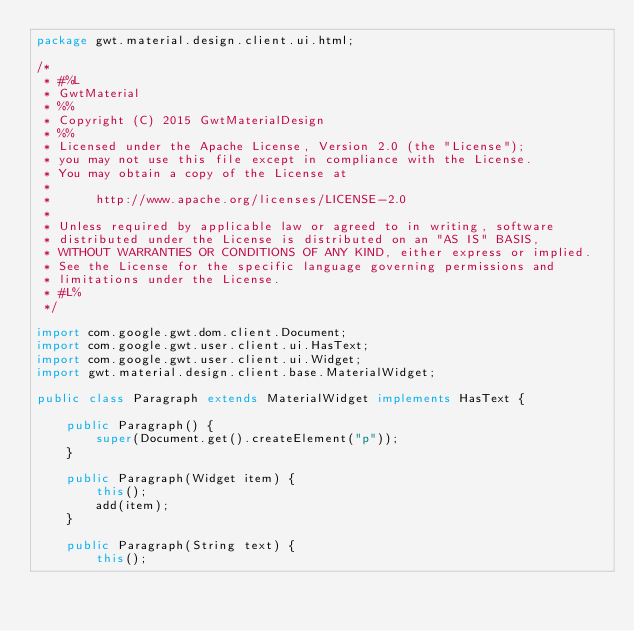Convert code to text. <code><loc_0><loc_0><loc_500><loc_500><_Java_>package gwt.material.design.client.ui.html;

/*
 * #%L
 * GwtMaterial
 * %%
 * Copyright (C) 2015 GwtMaterialDesign
 * %%
 * Licensed under the Apache License, Version 2.0 (the "License");
 * you may not use this file except in compliance with the License.
 * You may obtain a copy of the License at
 * 
 *      http://www.apache.org/licenses/LICENSE-2.0
 * 
 * Unless required by applicable law or agreed to in writing, software
 * distributed under the License is distributed on an "AS IS" BASIS,
 * WITHOUT WARRANTIES OR CONDITIONS OF ANY KIND, either express or implied.
 * See the License for the specific language governing permissions and
 * limitations under the License.
 * #L%
 */

import com.google.gwt.dom.client.Document;
import com.google.gwt.user.client.ui.HasText;
import com.google.gwt.user.client.ui.Widget;
import gwt.material.design.client.base.MaterialWidget;

public class Paragraph extends MaterialWidget implements HasText {

    public Paragraph() {
        super(Document.get().createElement("p"));
    }

    public Paragraph(Widget item) {
        this();
        add(item);
    }

    public Paragraph(String text) {
        this();</code> 